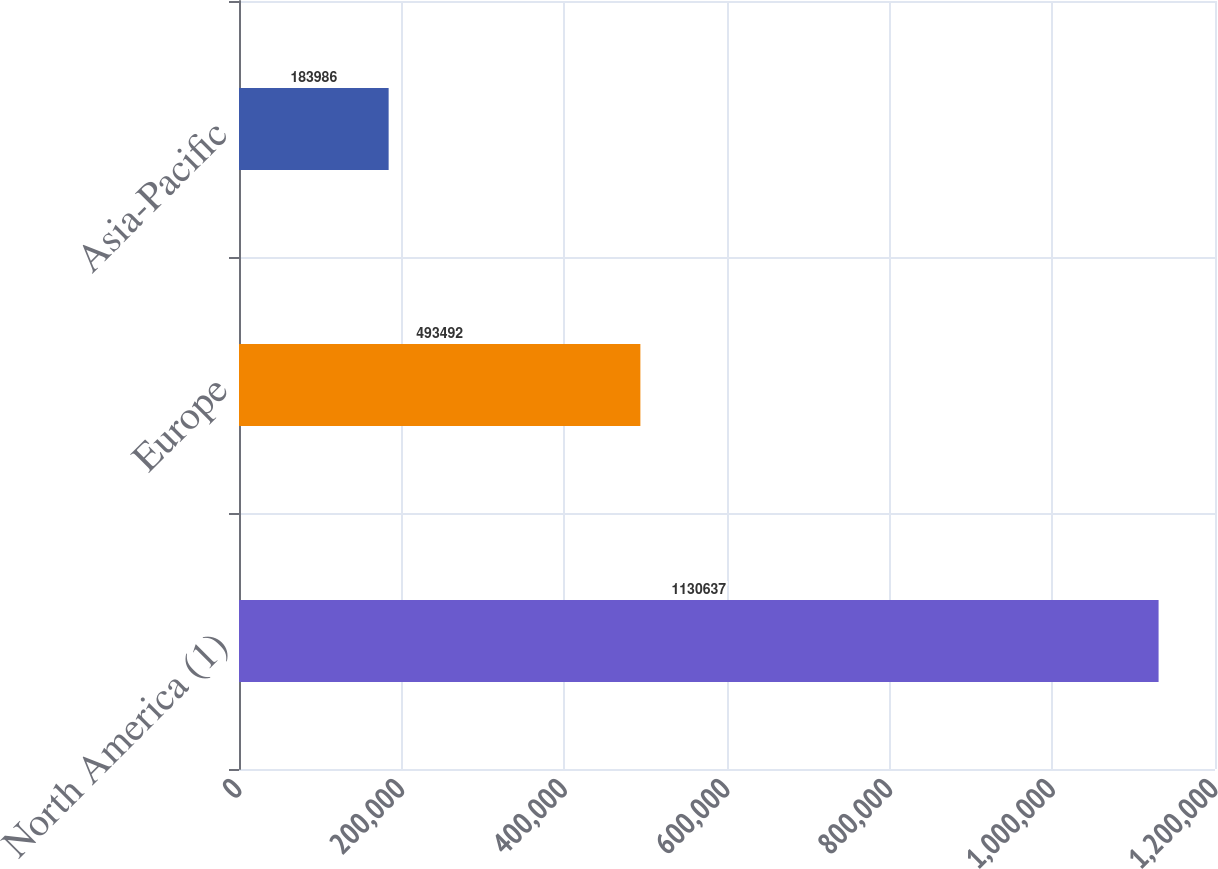<chart> <loc_0><loc_0><loc_500><loc_500><bar_chart><fcel>North America (1)<fcel>Europe<fcel>Asia-Pacific<nl><fcel>1.13064e+06<fcel>493492<fcel>183986<nl></chart> 